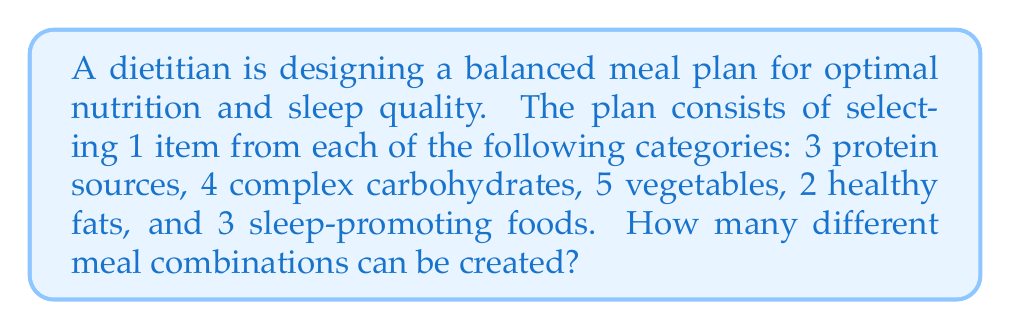Give your solution to this math problem. To solve this problem, we'll use the multiplication principle of counting. Since we're selecting one item from each category, and the selections are independent of each other, we multiply the number of choices for each category:

1. Protein sources: 3 choices
2. Complex carbohydrates: 4 choices
3. Vegetables: 5 choices
4. Healthy fats: 2 choices
5. Sleep-promoting foods: 3 choices

The total number of possible meal combinations is:

$$ 3 \times 4 \times 5 \times 2 \times 3 = 360 $$

This calculation gives us the total number of ways to select one item from each category, resulting in a balanced meal that supports both nutrition and sleep quality.
Answer: 360 combinations 